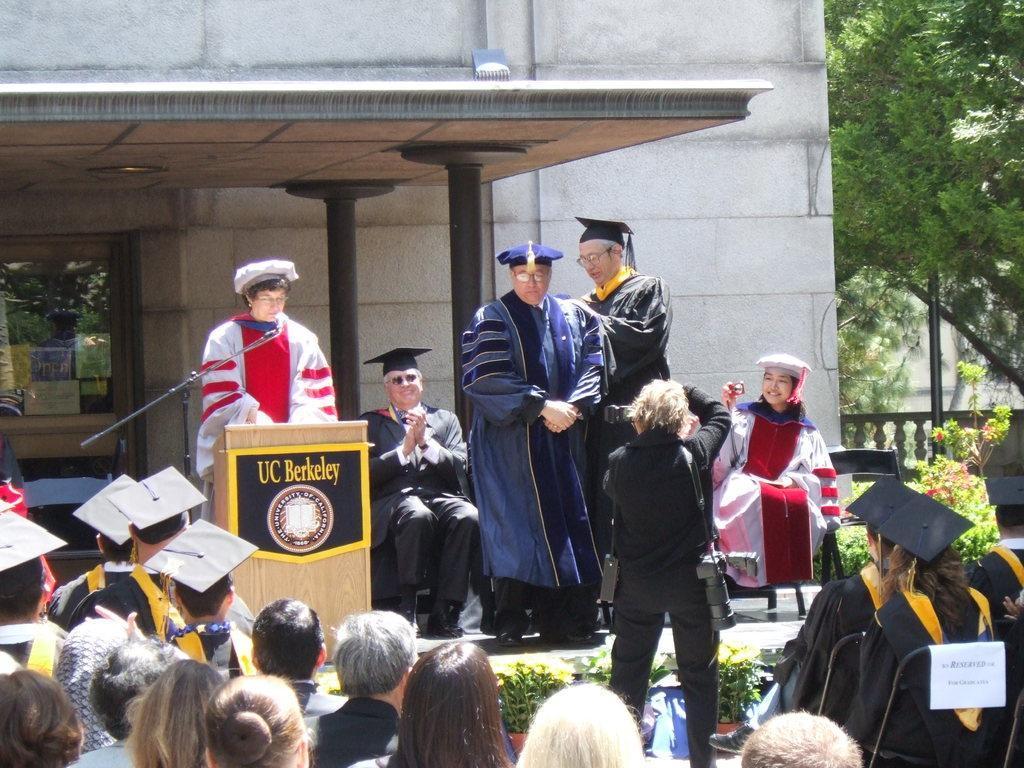How would you summarize this image in a sentence or two? In this picture there are people at the bottom side of the image, they are wearing apron and there are other people on the stage, there is a lady on the stage in front of a desk and there is a building in the background area of the image, there are trees on the right side of the image. 